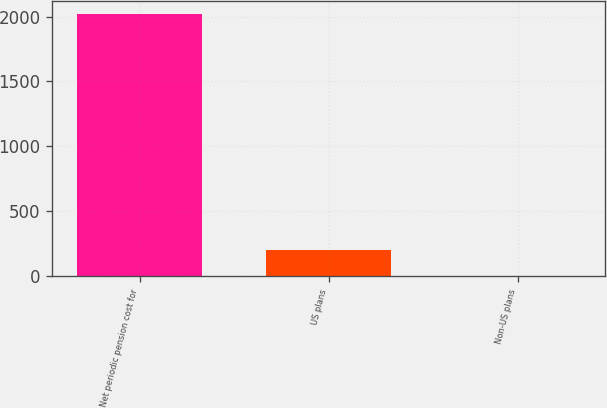Convert chart. <chart><loc_0><loc_0><loc_500><loc_500><bar_chart><fcel>Net periodic pension cost for<fcel>US plans<fcel>Non-US plans<nl><fcel>2016<fcel>204.93<fcel>3.7<nl></chart> 